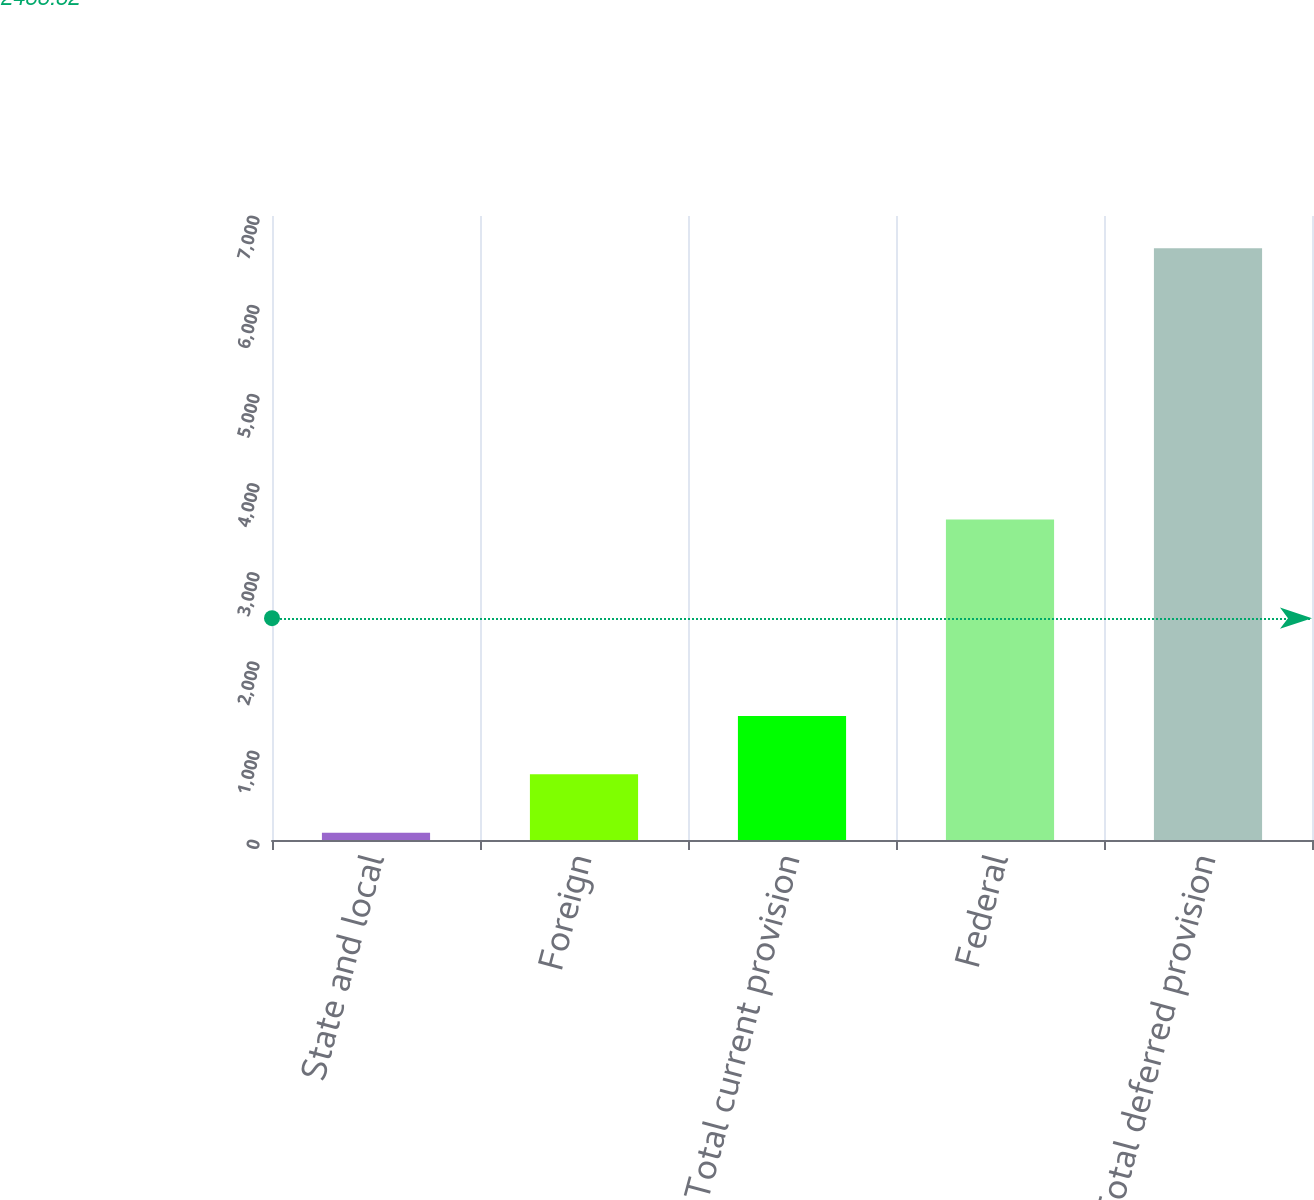Convert chart to OTSL. <chart><loc_0><loc_0><loc_500><loc_500><bar_chart><fcel>State and local<fcel>Foreign<fcel>Total current provision<fcel>Federal<fcel>Total deferred provision<nl><fcel>81<fcel>736.7<fcel>1392.4<fcel>3596<fcel>6638<nl></chart> 